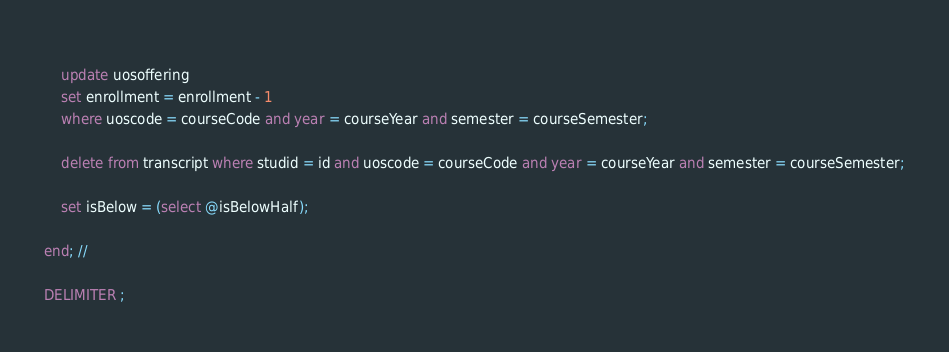<code> <loc_0><loc_0><loc_500><loc_500><_SQL_>	
	update uosoffering
    set enrollment = enrollment - 1
    where uoscode = courseCode and year = courseYear and semester = courseSemester;
    
    delete from transcript where studid = id and uoscode = courseCode and year = courseYear and semester = courseSemester;
    
    set isBelow = (select @isBelowHalf);
    
end; //

DELIMITER ;</code> 